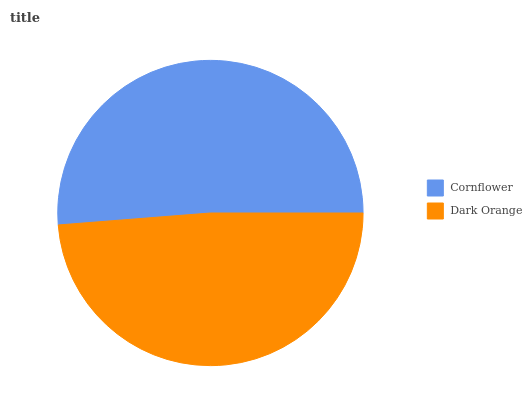Is Dark Orange the minimum?
Answer yes or no. Yes. Is Cornflower the maximum?
Answer yes or no. Yes. Is Dark Orange the maximum?
Answer yes or no. No. Is Cornflower greater than Dark Orange?
Answer yes or no. Yes. Is Dark Orange less than Cornflower?
Answer yes or no. Yes. Is Dark Orange greater than Cornflower?
Answer yes or no. No. Is Cornflower less than Dark Orange?
Answer yes or no. No. Is Cornflower the high median?
Answer yes or no. Yes. Is Dark Orange the low median?
Answer yes or no. Yes. Is Dark Orange the high median?
Answer yes or no. No. Is Cornflower the low median?
Answer yes or no. No. 